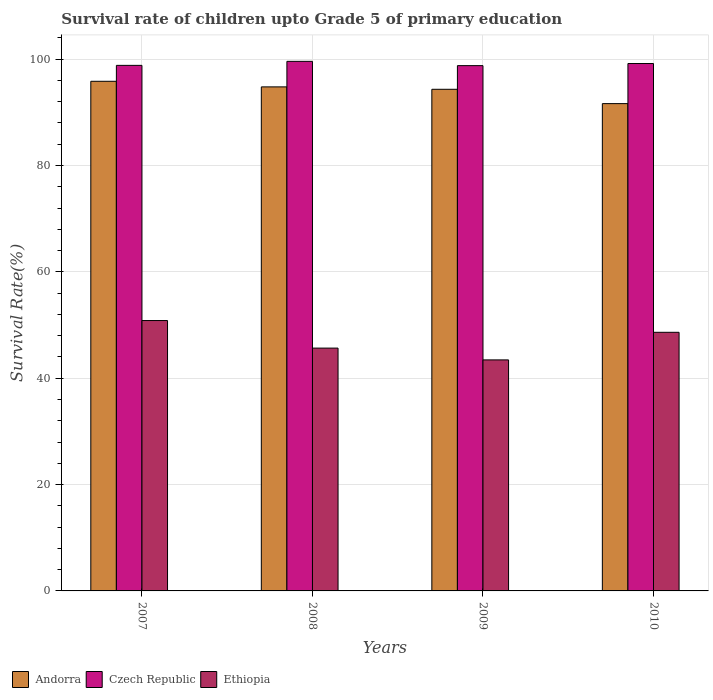Are the number of bars per tick equal to the number of legend labels?
Provide a short and direct response. Yes. Are the number of bars on each tick of the X-axis equal?
Offer a terse response. Yes. How many bars are there on the 4th tick from the right?
Keep it short and to the point. 3. In how many cases, is the number of bars for a given year not equal to the number of legend labels?
Make the answer very short. 0. What is the survival rate of children in Czech Republic in 2008?
Your response must be concise. 99.58. Across all years, what is the maximum survival rate of children in Czech Republic?
Your answer should be compact. 99.58. Across all years, what is the minimum survival rate of children in Czech Republic?
Ensure brevity in your answer.  98.78. What is the total survival rate of children in Czech Republic in the graph?
Ensure brevity in your answer.  396.37. What is the difference between the survival rate of children in Andorra in 2009 and that in 2010?
Your response must be concise. 2.69. What is the difference between the survival rate of children in Andorra in 2010 and the survival rate of children in Czech Republic in 2009?
Keep it short and to the point. -7.14. What is the average survival rate of children in Ethiopia per year?
Give a very brief answer. 47.15. In the year 2007, what is the difference between the survival rate of children in Ethiopia and survival rate of children in Czech Republic?
Make the answer very short. -47.99. What is the ratio of the survival rate of children in Czech Republic in 2007 to that in 2008?
Provide a short and direct response. 0.99. Is the difference between the survival rate of children in Ethiopia in 2008 and 2009 greater than the difference between the survival rate of children in Czech Republic in 2008 and 2009?
Your answer should be compact. Yes. What is the difference between the highest and the second highest survival rate of children in Ethiopia?
Your answer should be very brief. 2.21. What is the difference between the highest and the lowest survival rate of children in Czech Republic?
Give a very brief answer. 0.8. In how many years, is the survival rate of children in Czech Republic greater than the average survival rate of children in Czech Republic taken over all years?
Keep it short and to the point. 2. What does the 2nd bar from the left in 2009 represents?
Your response must be concise. Czech Republic. What does the 3rd bar from the right in 2010 represents?
Offer a very short reply. Andorra. Is it the case that in every year, the sum of the survival rate of children in Ethiopia and survival rate of children in Czech Republic is greater than the survival rate of children in Andorra?
Give a very brief answer. Yes. What is the difference between two consecutive major ticks on the Y-axis?
Give a very brief answer. 20. Does the graph contain any zero values?
Give a very brief answer. No. Where does the legend appear in the graph?
Provide a short and direct response. Bottom left. What is the title of the graph?
Give a very brief answer. Survival rate of children upto Grade 5 of primary education. Does "Sint Maarten (Dutch part)" appear as one of the legend labels in the graph?
Provide a short and direct response. No. What is the label or title of the X-axis?
Keep it short and to the point. Years. What is the label or title of the Y-axis?
Keep it short and to the point. Survival Rate(%). What is the Survival Rate(%) in Andorra in 2007?
Your answer should be very brief. 95.84. What is the Survival Rate(%) in Czech Republic in 2007?
Provide a succinct answer. 98.83. What is the Survival Rate(%) in Ethiopia in 2007?
Make the answer very short. 50.84. What is the Survival Rate(%) in Andorra in 2008?
Give a very brief answer. 94.78. What is the Survival Rate(%) of Czech Republic in 2008?
Give a very brief answer. 99.58. What is the Survival Rate(%) of Ethiopia in 2008?
Provide a short and direct response. 45.66. What is the Survival Rate(%) of Andorra in 2009?
Provide a short and direct response. 94.33. What is the Survival Rate(%) of Czech Republic in 2009?
Your response must be concise. 98.78. What is the Survival Rate(%) in Ethiopia in 2009?
Keep it short and to the point. 43.44. What is the Survival Rate(%) in Andorra in 2010?
Offer a very short reply. 91.64. What is the Survival Rate(%) of Czech Republic in 2010?
Provide a short and direct response. 99.18. What is the Survival Rate(%) in Ethiopia in 2010?
Your answer should be compact. 48.63. Across all years, what is the maximum Survival Rate(%) in Andorra?
Your response must be concise. 95.84. Across all years, what is the maximum Survival Rate(%) of Czech Republic?
Provide a short and direct response. 99.58. Across all years, what is the maximum Survival Rate(%) in Ethiopia?
Give a very brief answer. 50.84. Across all years, what is the minimum Survival Rate(%) in Andorra?
Keep it short and to the point. 91.64. Across all years, what is the minimum Survival Rate(%) in Czech Republic?
Keep it short and to the point. 98.78. Across all years, what is the minimum Survival Rate(%) of Ethiopia?
Ensure brevity in your answer.  43.44. What is the total Survival Rate(%) in Andorra in the graph?
Provide a short and direct response. 376.59. What is the total Survival Rate(%) of Czech Republic in the graph?
Make the answer very short. 396.37. What is the total Survival Rate(%) in Ethiopia in the graph?
Make the answer very short. 188.58. What is the difference between the Survival Rate(%) in Andorra in 2007 and that in 2008?
Your answer should be compact. 1.05. What is the difference between the Survival Rate(%) of Czech Republic in 2007 and that in 2008?
Provide a short and direct response. -0.75. What is the difference between the Survival Rate(%) of Ethiopia in 2007 and that in 2008?
Make the answer very short. 5.18. What is the difference between the Survival Rate(%) of Andorra in 2007 and that in 2009?
Offer a terse response. 1.51. What is the difference between the Survival Rate(%) in Czech Republic in 2007 and that in 2009?
Ensure brevity in your answer.  0.05. What is the difference between the Survival Rate(%) in Ethiopia in 2007 and that in 2009?
Ensure brevity in your answer.  7.4. What is the difference between the Survival Rate(%) in Andorra in 2007 and that in 2010?
Provide a short and direct response. 4.2. What is the difference between the Survival Rate(%) in Czech Republic in 2007 and that in 2010?
Make the answer very short. -0.35. What is the difference between the Survival Rate(%) in Ethiopia in 2007 and that in 2010?
Your answer should be compact. 2.21. What is the difference between the Survival Rate(%) of Andorra in 2008 and that in 2009?
Provide a succinct answer. 0.45. What is the difference between the Survival Rate(%) in Czech Republic in 2008 and that in 2009?
Give a very brief answer. 0.8. What is the difference between the Survival Rate(%) in Ethiopia in 2008 and that in 2009?
Make the answer very short. 2.22. What is the difference between the Survival Rate(%) in Andorra in 2008 and that in 2010?
Offer a terse response. 3.15. What is the difference between the Survival Rate(%) of Czech Republic in 2008 and that in 2010?
Keep it short and to the point. 0.41. What is the difference between the Survival Rate(%) in Ethiopia in 2008 and that in 2010?
Your response must be concise. -2.97. What is the difference between the Survival Rate(%) in Andorra in 2009 and that in 2010?
Your answer should be very brief. 2.69. What is the difference between the Survival Rate(%) in Czech Republic in 2009 and that in 2010?
Make the answer very short. -0.4. What is the difference between the Survival Rate(%) in Ethiopia in 2009 and that in 2010?
Give a very brief answer. -5.19. What is the difference between the Survival Rate(%) of Andorra in 2007 and the Survival Rate(%) of Czech Republic in 2008?
Your answer should be very brief. -3.75. What is the difference between the Survival Rate(%) in Andorra in 2007 and the Survival Rate(%) in Ethiopia in 2008?
Provide a short and direct response. 50.17. What is the difference between the Survival Rate(%) of Czech Republic in 2007 and the Survival Rate(%) of Ethiopia in 2008?
Your response must be concise. 53.17. What is the difference between the Survival Rate(%) of Andorra in 2007 and the Survival Rate(%) of Czech Republic in 2009?
Give a very brief answer. -2.94. What is the difference between the Survival Rate(%) of Andorra in 2007 and the Survival Rate(%) of Ethiopia in 2009?
Ensure brevity in your answer.  52.39. What is the difference between the Survival Rate(%) in Czech Republic in 2007 and the Survival Rate(%) in Ethiopia in 2009?
Provide a succinct answer. 55.39. What is the difference between the Survival Rate(%) of Andorra in 2007 and the Survival Rate(%) of Czech Republic in 2010?
Keep it short and to the point. -3.34. What is the difference between the Survival Rate(%) in Andorra in 2007 and the Survival Rate(%) in Ethiopia in 2010?
Offer a terse response. 47.21. What is the difference between the Survival Rate(%) in Czech Republic in 2007 and the Survival Rate(%) in Ethiopia in 2010?
Give a very brief answer. 50.2. What is the difference between the Survival Rate(%) of Andorra in 2008 and the Survival Rate(%) of Czech Republic in 2009?
Provide a succinct answer. -4. What is the difference between the Survival Rate(%) in Andorra in 2008 and the Survival Rate(%) in Ethiopia in 2009?
Give a very brief answer. 51.34. What is the difference between the Survival Rate(%) in Czech Republic in 2008 and the Survival Rate(%) in Ethiopia in 2009?
Your answer should be very brief. 56.14. What is the difference between the Survival Rate(%) in Andorra in 2008 and the Survival Rate(%) in Czech Republic in 2010?
Offer a very short reply. -4.39. What is the difference between the Survival Rate(%) of Andorra in 2008 and the Survival Rate(%) of Ethiopia in 2010?
Offer a terse response. 46.15. What is the difference between the Survival Rate(%) of Czech Republic in 2008 and the Survival Rate(%) of Ethiopia in 2010?
Give a very brief answer. 50.95. What is the difference between the Survival Rate(%) of Andorra in 2009 and the Survival Rate(%) of Czech Republic in 2010?
Your response must be concise. -4.85. What is the difference between the Survival Rate(%) in Andorra in 2009 and the Survival Rate(%) in Ethiopia in 2010?
Provide a succinct answer. 45.7. What is the difference between the Survival Rate(%) of Czech Republic in 2009 and the Survival Rate(%) of Ethiopia in 2010?
Your answer should be compact. 50.15. What is the average Survival Rate(%) in Andorra per year?
Provide a succinct answer. 94.15. What is the average Survival Rate(%) of Czech Republic per year?
Ensure brevity in your answer.  99.09. What is the average Survival Rate(%) of Ethiopia per year?
Your response must be concise. 47.15. In the year 2007, what is the difference between the Survival Rate(%) of Andorra and Survival Rate(%) of Czech Republic?
Offer a very short reply. -2.99. In the year 2007, what is the difference between the Survival Rate(%) in Andorra and Survival Rate(%) in Ethiopia?
Provide a short and direct response. 44.99. In the year 2007, what is the difference between the Survival Rate(%) in Czech Republic and Survival Rate(%) in Ethiopia?
Ensure brevity in your answer.  47.99. In the year 2008, what is the difference between the Survival Rate(%) of Andorra and Survival Rate(%) of Czech Republic?
Give a very brief answer. -4.8. In the year 2008, what is the difference between the Survival Rate(%) of Andorra and Survival Rate(%) of Ethiopia?
Offer a terse response. 49.12. In the year 2008, what is the difference between the Survival Rate(%) of Czech Republic and Survival Rate(%) of Ethiopia?
Provide a short and direct response. 53.92. In the year 2009, what is the difference between the Survival Rate(%) of Andorra and Survival Rate(%) of Czech Republic?
Provide a succinct answer. -4.45. In the year 2009, what is the difference between the Survival Rate(%) in Andorra and Survival Rate(%) in Ethiopia?
Offer a very short reply. 50.89. In the year 2009, what is the difference between the Survival Rate(%) of Czech Republic and Survival Rate(%) of Ethiopia?
Your response must be concise. 55.34. In the year 2010, what is the difference between the Survival Rate(%) in Andorra and Survival Rate(%) in Czech Republic?
Provide a succinct answer. -7.54. In the year 2010, what is the difference between the Survival Rate(%) of Andorra and Survival Rate(%) of Ethiopia?
Provide a short and direct response. 43. In the year 2010, what is the difference between the Survival Rate(%) in Czech Republic and Survival Rate(%) in Ethiopia?
Give a very brief answer. 50.54. What is the ratio of the Survival Rate(%) of Andorra in 2007 to that in 2008?
Keep it short and to the point. 1.01. What is the ratio of the Survival Rate(%) of Czech Republic in 2007 to that in 2008?
Your answer should be compact. 0.99. What is the ratio of the Survival Rate(%) in Ethiopia in 2007 to that in 2008?
Your answer should be compact. 1.11. What is the ratio of the Survival Rate(%) of Ethiopia in 2007 to that in 2009?
Give a very brief answer. 1.17. What is the ratio of the Survival Rate(%) in Andorra in 2007 to that in 2010?
Provide a succinct answer. 1.05. What is the ratio of the Survival Rate(%) of Czech Republic in 2007 to that in 2010?
Your answer should be compact. 1. What is the ratio of the Survival Rate(%) of Ethiopia in 2007 to that in 2010?
Your answer should be very brief. 1.05. What is the ratio of the Survival Rate(%) in Andorra in 2008 to that in 2009?
Offer a terse response. 1. What is the ratio of the Survival Rate(%) of Czech Republic in 2008 to that in 2009?
Make the answer very short. 1.01. What is the ratio of the Survival Rate(%) in Ethiopia in 2008 to that in 2009?
Keep it short and to the point. 1.05. What is the ratio of the Survival Rate(%) in Andorra in 2008 to that in 2010?
Offer a very short reply. 1.03. What is the ratio of the Survival Rate(%) of Czech Republic in 2008 to that in 2010?
Give a very brief answer. 1. What is the ratio of the Survival Rate(%) of Ethiopia in 2008 to that in 2010?
Your response must be concise. 0.94. What is the ratio of the Survival Rate(%) of Andorra in 2009 to that in 2010?
Give a very brief answer. 1.03. What is the ratio of the Survival Rate(%) of Czech Republic in 2009 to that in 2010?
Provide a short and direct response. 1. What is the ratio of the Survival Rate(%) of Ethiopia in 2009 to that in 2010?
Provide a succinct answer. 0.89. What is the difference between the highest and the second highest Survival Rate(%) in Andorra?
Offer a terse response. 1.05. What is the difference between the highest and the second highest Survival Rate(%) in Czech Republic?
Your answer should be very brief. 0.41. What is the difference between the highest and the second highest Survival Rate(%) in Ethiopia?
Provide a short and direct response. 2.21. What is the difference between the highest and the lowest Survival Rate(%) in Andorra?
Ensure brevity in your answer.  4.2. What is the difference between the highest and the lowest Survival Rate(%) of Czech Republic?
Make the answer very short. 0.8. What is the difference between the highest and the lowest Survival Rate(%) of Ethiopia?
Ensure brevity in your answer.  7.4. 